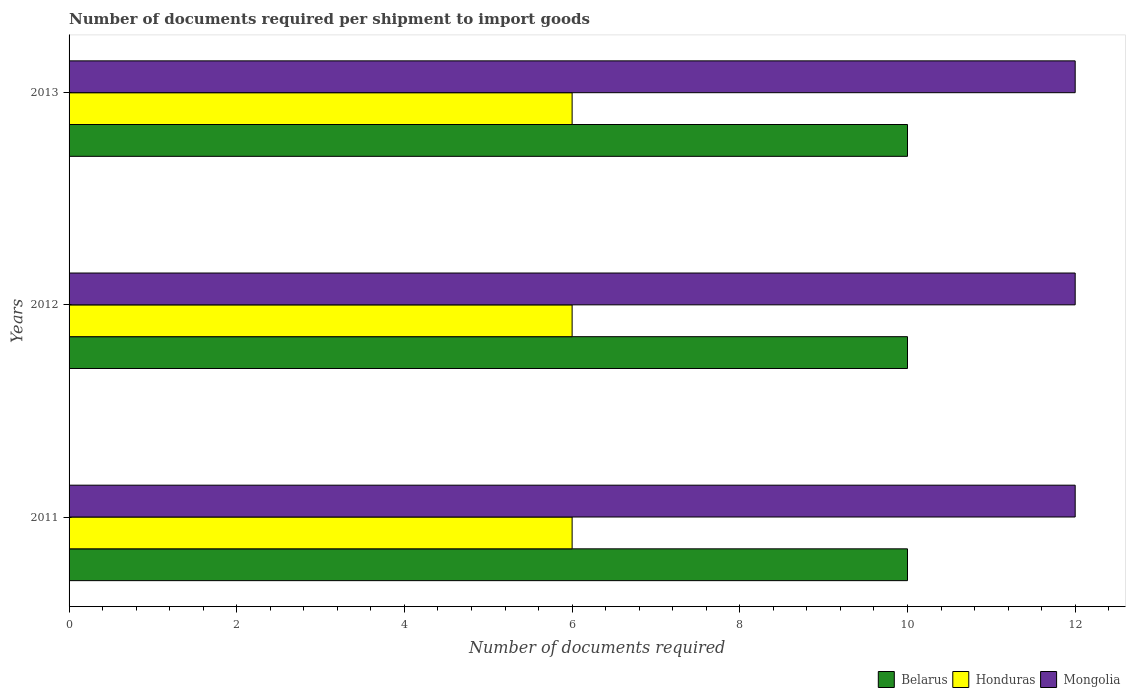How many different coloured bars are there?
Ensure brevity in your answer.  3. Are the number of bars on each tick of the Y-axis equal?
Provide a succinct answer. Yes. How many bars are there on the 2nd tick from the top?
Your answer should be compact. 3. How many bars are there on the 1st tick from the bottom?
Offer a terse response. 3. In how many cases, is the number of bars for a given year not equal to the number of legend labels?
Give a very brief answer. 0. What is the number of documents required per shipment to import goods in Belarus in 2012?
Keep it short and to the point. 10. Across all years, what is the maximum number of documents required per shipment to import goods in Belarus?
Ensure brevity in your answer.  10. Across all years, what is the minimum number of documents required per shipment to import goods in Belarus?
Your answer should be very brief. 10. In which year was the number of documents required per shipment to import goods in Mongolia maximum?
Ensure brevity in your answer.  2011. What is the total number of documents required per shipment to import goods in Honduras in the graph?
Keep it short and to the point. 18. What is the difference between the number of documents required per shipment to import goods in Honduras in 2013 and the number of documents required per shipment to import goods in Mongolia in 2012?
Your answer should be compact. -6. What is the average number of documents required per shipment to import goods in Belarus per year?
Your response must be concise. 10. In the year 2011, what is the difference between the number of documents required per shipment to import goods in Honduras and number of documents required per shipment to import goods in Mongolia?
Give a very brief answer. -6. In how many years, is the number of documents required per shipment to import goods in Belarus greater than 4 ?
Ensure brevity in your answer.  3. What is the difference between the highest and the second highest number of documents required per shipment to import goods in Honduras?
Your answer should be very brief. 0. In how many years, is the number of documents required per shipment to import goods in Honduras greater than the average number of documents required per shipment to import goods in Honduras taken over all years?
Provide a succinct answer. 0. Is the sum of the number of documents required per shipment to import goods in Mongolia in 2011 and 2012 greater than the maximum number of documents required per shipment to import goods in Honduras across all years?
Ensure brevity in your answer.  Yes. What does the 2nd bar from the top in 2013 represents?
Make the answer very short. Honduras. What does the 2nd bar from the bottom in 2011 represents?
Your answer should be compact. Honduras. Is it the case that in every year, the sum of the number of documents required per shipment to import goods in Mongolia and number of documents required per shipment to import goods in Honduras is greater than the number of documents required per shipment to import goods in Belarus?
Offer a terse response. Yes. How many bars are there?
Make the answer very short. 9. How many years are there in the graph?
Make the answer very short. 3. Are the values on the major ticks of X-axis written in scientific E-notation?
Offer a very short reply. No. How many legend labels are there?
Ensure brevity in your answer.  3. What is the title of the graph?
Ensure brevity in your answer.  Number of documents required per shipment to import goods. What is the label or title of the X-axis?
Make the answer very short. Number of documents required. What is the Number of documents required of Honduras in 2012?
Your answer should be compact. 6. What is the Number of documents required of Mongolia in 2012?
Your answer should be compact. 12. What is the Number of documents required of Belarus in 2013?
Your answer should be very brief. 10. What is the Number of documents required of Honduras in 2013?
Your answer should be compact. 6. What is the Number of documents required of Mongolia in 2013?
Offer a very short reply. 12. Across all years, what is the maximum Number of documents required of Mongolia?
Make the answer very short. 12. What is the total Number of documents required of Belarus in the graph?
Give a very brief answer. 30. What is the total Number of documents required in Honduras in the graph?
Give a very brief answer. 18. What is the difference between the Number of documents required of Mongolia in 2011 and that in 2012?
Make the answer very short. 0. What is the difference between the Number of documents required in Belarus in 2011 and that in 2013?
Provide a succinct answer. 0. What is the difference between the Number of documents required of Mongolia in 2011 and that in 2013?
Your answer should be very brief. 0. What is the difference between the Number of documents required of Belarus in 2012 and that in 2013?
Your answer should be compact. 0. What is the difference between the Number of documents required of Belarus in 2012 and the Number of documents required of Mongolia in 2013?
Give a very brief answer. -2. What is the difference between the Number of documents required in Honduras in 2012 and the Number of documents required in Mongolia in 2013?
Ensure brevity in your answer.  -6. What is the average Number of documents required in Honduras per year?
Provide a short and direct response. 6. In the year 2011, what is the difference between the Number of documents required of Belarus and Number of documents required of Honduras?
Your answer should be compact. 4. In the year 2012, what is the difference between the Number of documents required in Belarus and Number of documents required in Mongolia?
Your answer should be very brief. -2. In the year 2012, what is the difference between the Number of documents required of Honduras and Number of documents required of Mongolia?
Provide a succinct answer. -6. In the year 2013, what is the difference between the Number of documents required in Belarus and Number of documents required in Honduras?
Give a very brief answer. 4. In the year 2013, what is the difference between the Number of documents required in Belarus and Number of documents required in Mongolia?
Provide a succinct answer. -2. In the year 2013, what is the difference between the Number of documents required of Honduras and Number of documents required of Mongolia?
Your response must be concise. -6. What is the ratio of the Number of documents required of Belarus in 2011 to that in 2012?
Provide a short and direct response. 1. What is the ratio of the Number of documents required of Honduras in 2011 to that in 2012?
Ensure brevity in your answer.  1. What is the ratio of the Number of documents required in Belarus in 2011 to that in 2013?
Make the answer very short. 1. What is the ratio of the Number of documents required of Honduras in 2012 to that in 2013?
Ensure brevity in your answer.  1. What is the ratio of the Number of documents required of Mongolia in 2012 to that in 2013?
Keep it short and to the point. 1. What is the difference between the highest and the second highest Number of documents required of Honduras?
Ensure brevity in your answer.  0. What is the difference between the highest and the second highest Number of documents required of Mongolia?
Ensure brevity in your answer.  0. 